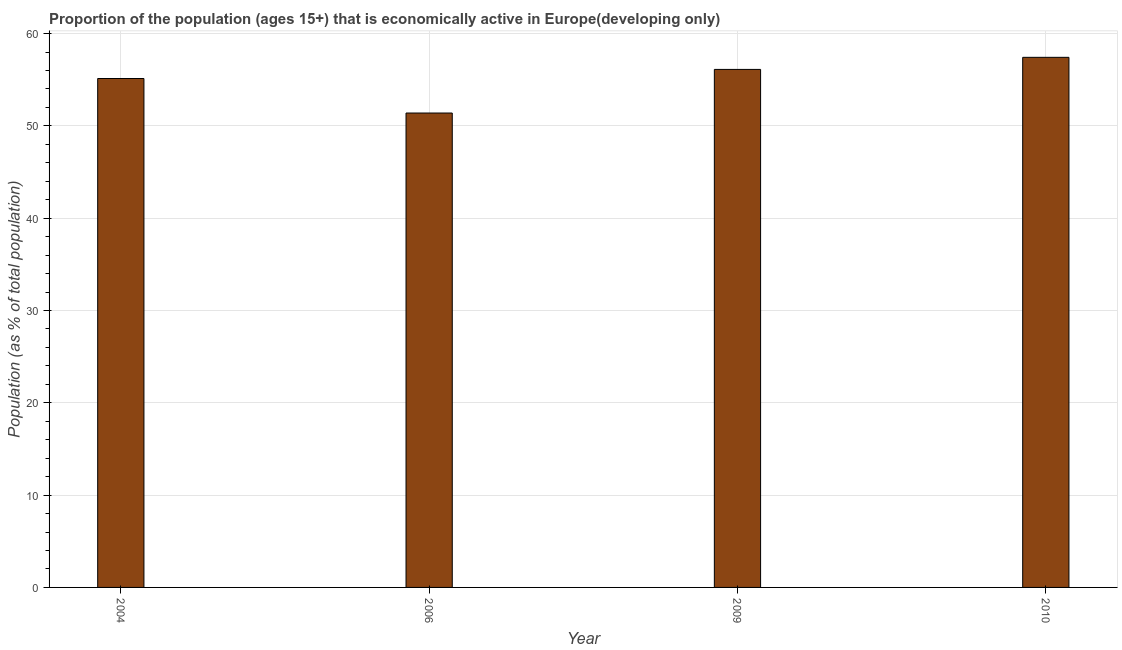Does the graph contain grids?
Your response must be concise. Yes. What is the title of the graph?
Provide a succinct answer. Proportion of the population (ages 15+) that is economically active in Europe(developing only). What is the label or title of the X-axis?
Offer a terse response. Year. What is the label or title of the Y-axis?
Offer a terse response. Population (as % of total population). What is the percentage of economically active population in 2004?
Keep it short and to the point. 55.13. Across all years, what is the maximum percentage of economically active population?
Give a very brief answer. 57.43. Across all years, what is the minimum percentage of economically active population?
Give a very brief answer. 51.39. In which year was the percentage of economically active population maximum?
Your answer should be compact. 2010. What is the sum of the percentage of economically active population?
Make the answer very short. 220.07. What is the difference between the percentage of economically active population in 2004 and 2006?
Your answer should be very brief. 3.74. What is the average percentage of economically active population per year?
Provide a short and direct response. 55.02. What is the median percentage of economically active population?
Your response must be concise. 55.62. In how many years, is the percentage of economically active population greater than 50 %?
Your answer should be compact. 4. What is the ratio of the percentage of economically active population in 2004 to that in 2010?
Your answer should be compact. 0.96. Is the difference between the percentage of economically active population in 2004 and 2010 greater than the difference between any two years?
Your answer should be very brief. No. What is the difference between the highest and the second highest percentage of economically active population?
Provide a succinct answer. 1.31. What is the difference between the highest and the lowest percentage of economically active population?
Your answer should be compact. 6.03. How many years are there in the graph?
Make the answer very short. 4. Are the values on the major ticks of Y-axis written in scientific E-notation?
Your response must be concise. No. What is the Population (as % of total population) of 2004?
Ensure brevity in your answer.  55.13. What is the Population (as % of total population) of 2006?
Provide a succinct answer. 51.39. What is the Population (as % of total population) of 2009?
Your answer should be compact. 56.12. What is the Population (as % of total population) in 2010?
Keep it short and to the point. 57.43. What is the difference between the Population (as % of total population) in 2004 and 2006?
Keep it short and to the point. 3.74. What is the difference between the Population (as % of total population) in 2004 and 2009?
Offer a terse response. -0.98. What is the difference between the Population (as % of total population) in 2004 and 2010?
Your response must be concise. -2.29. What is the difference between the Population (as % of total population) in 2006 and 2009?
Offer a very short reply. -4.72. What is the difference between the Population (as % of total population) in 2006 and 2010?
Provide a short and direct response. -6.03. What is the difference between the Population (as % of total population) in 2009 and 2010?
Keep it short and to the point. -1.31. What is the ratio of the Population (as % of total population) in 2004 to that in 2006?
Provide a short and direct response. 1.07. What is the ratio of the Population (as % of total population) in 2004 to that in 2009?
Your answer should be very brief. 0.98. What is the ratio of the Population (as % of total population) in 2004 to that in 2010?
Keep it short and to the point. 0.96. What is the ratio of the Population (as % of total population) in 2006 to that in 2009?
Make the answer very short. 0.92. What is the ratio of the Population (as % of total population) in 2006 to that in 2010?
Provide a short and direct response. 0.9. 